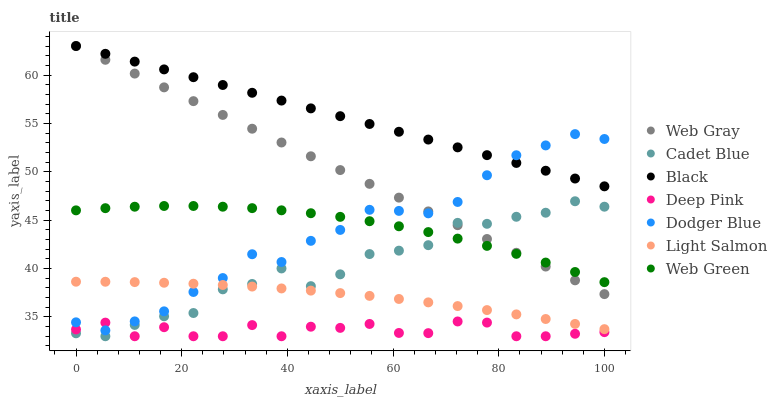Does Deep Pink have the minimum area under the curve?
Answer yes or no. Yes. Does Black have the maximum area under the curve?
Answer yes or no. Yes. Does Cadet Blue have the minimum area under the curve?
Answer yes or no. No. Does Cadet Blue have the maximum area under the curve?
Answer yes or no. No. Is Web Gray the smoothest?
Answer yes or no. Yes. Is Cadet Blue the roughest?
Answer yes or no. Yes. Is Deep Pink the smoothest?
Answer yes or no. No. Is Deep Pink the roughest?
Answer yes or no. No. Does Cadet Blue have the lowest value?
Answer yes or no. Yes. Does Web Gray have the lowest value?
Answer yes or no. No. Does Black have the highest value?
Answer yes or no. Yes. Does Cadet Blue have the highest value?
Answer yes or no. No. Is Light Salmon less than Web Gray?
Answer yes or no. Yes. Is Black greater than Light Salmon?
Answer yes or no. Yes. Does Web Green intersect Cadet Blue?
Answer yes or no. Yes. Is Web Green less than Cadet Blue?
Answer yes or no. No. Is Web Green greater than Cadet Blue?
Answer yes or no. No. Does Light Salmon intersect Web Gray?
Answer yes or no. No. 